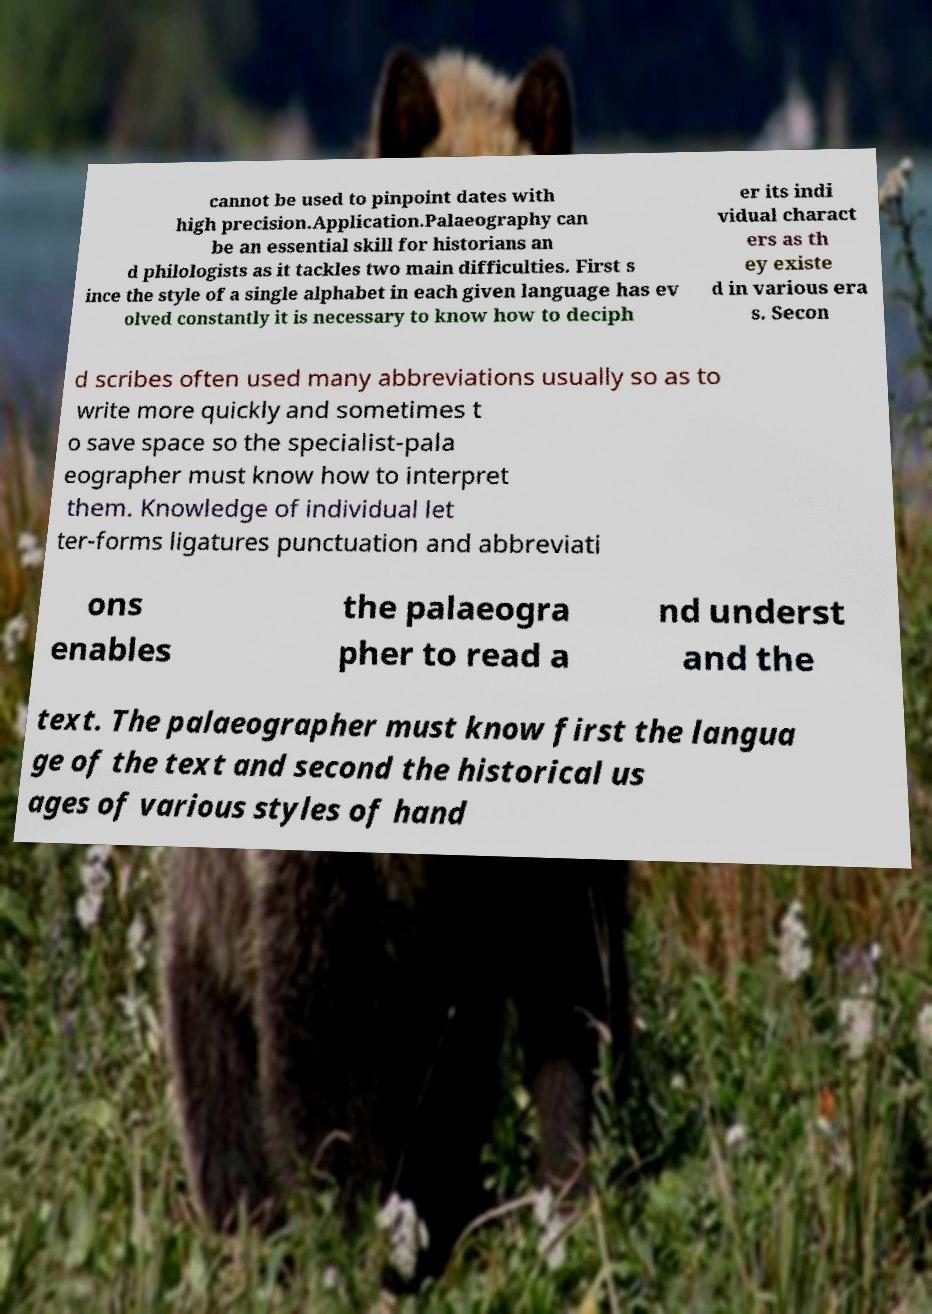Please identify and transcribe the text found in this image. cannot be used to pinpoint dates with high precision.Application.Palaeography can be an essential skill for historians an d philologists as it tackles two main difficulties. First s ince the style of a single alphabet in each given language has ev olved constantly it is necessary to know how to deciph er its indi vidual charact ers as th ey existe d in various era s. Secon d scribes often used many abbreviations usually so as to write more quickly and sometimes t o save space so the specialist-pala eographer must know how to interpret them. Knowledge of individual let ter-forms ligatures punctuation and abbreviati ons enables the palaeogra pher to read a nd underst and the text. The palaeographer must know first the langua ge of the text and second the historical us ages of various styles of hand 